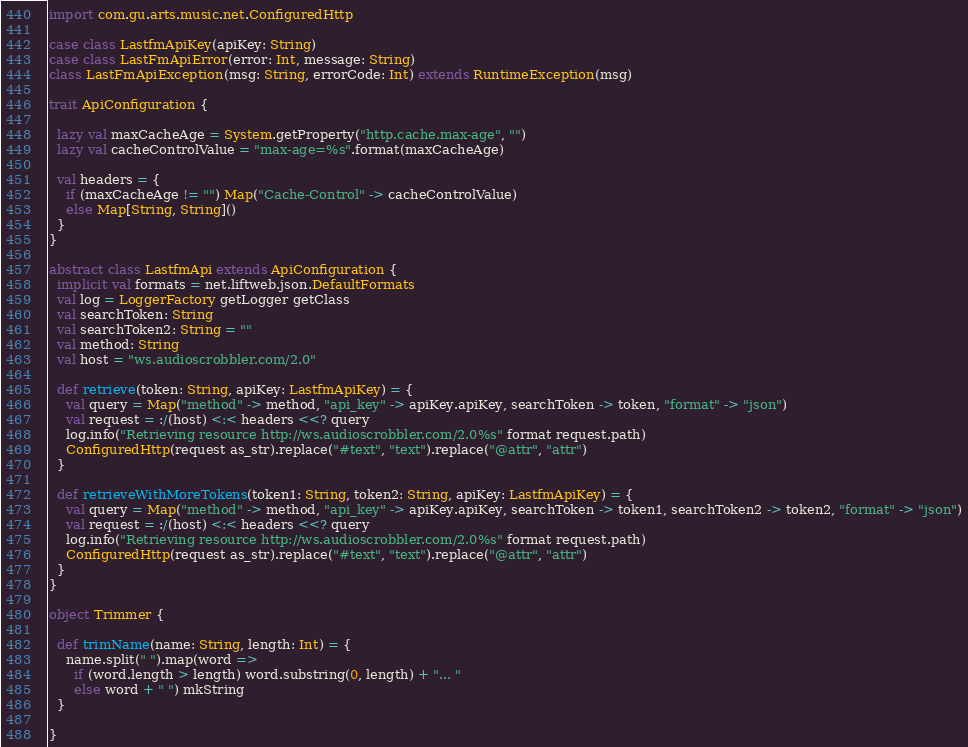Convert code to text. <code><loc_0><loc_0><loc_500><loc_500><_Scala_>import com.gu.arts.music.net.ConfiguredHttp

case class LastfmApiKey(apiKey: String)
case class LastFmApiError(error: Int, message: String)
class LastFmApiException(msg: String, errorCode: Int) extends RuntimeException(msg)

trait ApiConfiguration {

  lazy val maxCacheAge = System.getProperty("http.cache.max-age", "")
  lazy val cacheControlValue = "max-age=%s".format(maxCacheAge)

  val headers = {
    if (maxCacheAge != "") Map("Cache-Control" -> cacheControlValue)
    else Map[String, String]()
  }
}

abstract class LastfmApi extends ApiConfiguration {
  implicit val formats = net.liftweb.json.DefaultFormats
  val log = LoggerFactory getLogger getClass
  val searchToken: String
  val searchToken2: String = ""
  val method: String
  val host = "ws.audioscrobbler.com/2.0"

  def retrieve(token: String, apiKey: LastfmApiKey) = {
    val query = Map("method" -> method, "api_key" -> apiKey.apiKey, searchToken -> token, "format" -> "json")
    val request = :/(host) <:< headers <<? query
    log.info("Retrieving resource http://ws.audioscrobbler.com/2.0%s" format request.path)
    ConfiguredHttp(request as_str).replace("#text", "text").replace("@attr", "attr")
  }

  def retrieveWithMoreTokens(token1: String, token2: String, apiKey: LastfmApiKey) = {
    val query = Map("method" -> method, "api_key" -> apiKey.apiKey, searchToken -> token1, searchToken2 -> token2, "format" -> "json")
    val request = :/(host) <:< headers <<? query
    log.info("Retrieving resource http://ws.audioscrobbler.com/2.0%s" format request.path)
    ConfiguredHttp(request as_str).replace("#text", "text").replace("@attr", "attr")
  }
}

object Trimmer {

  def trimName(name: String, length: Int) = {
    name.split(" ").map(word =>
      if (word.length > length) word.substring(0, length) + "... "
      else word + " ") mkString
  }

}
</code> 